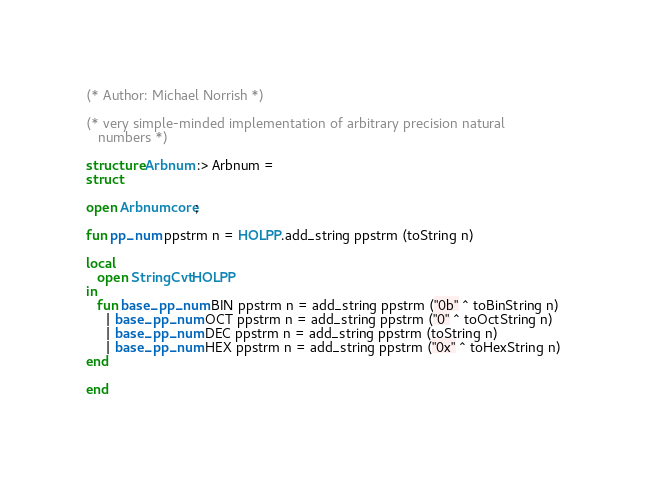Convert code to text. <code><loc_0><loc_0><loc_500><loc_500><_SML_>(* Author: Michael Norrish *)

(* very simple-minded implementation of arbitrary precision natural
   numbers *)

structure Arbnum :> Arbnum =
struct

open Arbnumcore;

fun pp_num ppstrm n = HOLPP.add_string ppstrm (toString n)

local
   open StringCvt HOLPP
in
   fun base_pp_num BIN ppstrm n = add_string ppstrm ("0b" ^ toBinString n)
     | base_pp_num OCT ppstrm n = add_string ppstrm ("0" ^ toOctString n)
     | base_pp_num DEC ppstrm n = add_string ppstrm (toString n)
     | base_pp_num HEX ppstrm n = add_string ppstrm ("0x" ^ toHexString n)
end

end
</code> 